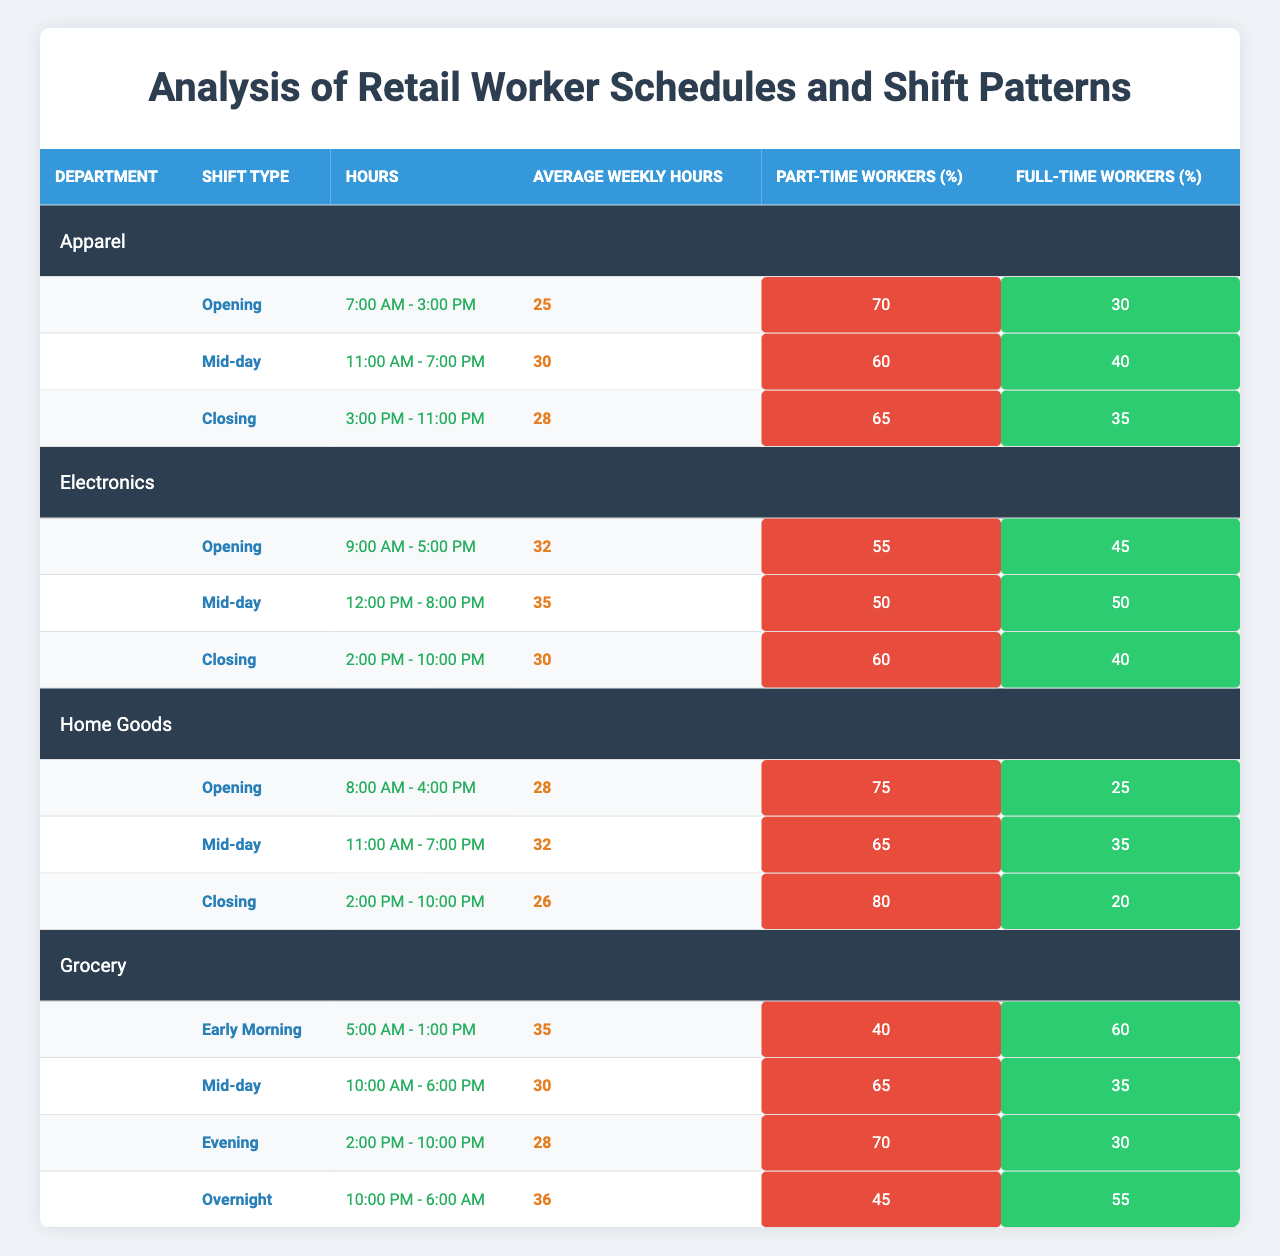What is the average weekly hours for the Apparel department's Mid-day shift? According to the table, the average weekly hours for the Mid-day shift in the Apparel department is listed directly as 30 hours.
Answer: 30 hours What percentage of part-time workers are there in the Grocery department's Early Morning shift? The table states that in the Grocery department's Early Morning shift, the percentage of part-time workers is 40%.
Answer: 40% Which department has the highest average weekly hours for shifts? By comparing the average weekly hours for each department's shifts, the Grocery department has the highest average at 35 hours for the Early Morning shift and 36 hours for the Overnight shift, leading to an overall average of 32.25 hours among its shifts.
Answer: Grocery Is the percentage of full-time workers higher in the Electronics department's Closing shift compared to the Apparel department's Closing shift? The Electronics department's Closing shift has 40% full-time workers, while the Apparel department's Closing shift has 35%. Since 40% is greater than 35%, the answer is yes.
Answer: Yes What is the total average weekly hours of all Mid-day shifts across all departments? The average weekly hours for Mid-day shifts are as follows: Apparel (30), Electronics (35), Home Goods (32), and Grocery (30). Adding these values leads to a total of 30 + 35 + 32 + 30 = 127 hours. Dividing by 4 (the number of Mid-day shifts) provides an average of 127/4 = 31.75 hours.
Answer: 31.75 hours Does the Apparel department have a higher percentage of full-time workers in the Opening shift than the Home Goods department? The Apparel department's Opening shift has 30% full-time workers while the Home Goods department's Opening shift has 25% full-time workers. Since 30% is greater than 25%, the answer is yes.
Answer: Yes How many total shifts are listed for the Grocery department? The table indicates that the Grocery department has four shifts listed: Early Morning, Mid-day, Evening, and Overnight. Therefore, there are 4 shifts in total.
Answer: 4 Which shift type in the Home Goods department has the lowest percentage of part-time workers? Among the shifts in the Home Goods department, the Closing shift has the lowest percentage of part-time workers at 80%.
Answer: Closing shift What is the average percentage of full-time workers across all departments? The percentage of full-time workers is as follows: Apparel (30% + 40% + 35%), Electronics (45% + 50% + 40%), Home Goods (25% + 35% + 20%), and Grocery (60% + 35% + 30% + 55%). Adding them gives 30 + 40 + 35 = 105; 45 + 50 + 40 = 135; 25 + 35 + 20 = 80; 60 + 35 + 30 + 55 = 180. The total is 105 + 135 + 80 + 180 = 500. The average based on 16 total shifts is 500/16 = 31.25%.
Answer: 31.25% In which department is the Mid-day shift associated with the highest average weekly hours? Searching through the Mid-day shifts, the Electronics department has the highest average weekly hours at 35.
Answer: Electronics How many more average weekly hours does the Electronics department's Mid-day shift have compared to the Apparel department's Mid-day shift? The average weekly hours for the Electronics Mid-day shift is 35 hours, and for the Apparel Mid-day shift, it is 30 hours. The difference is 35 - 30 = 5 hours.
Answer: 5 hours 